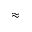<formula> <loc_0><loc_0><loc_500><loc_500>\approx</formula> 